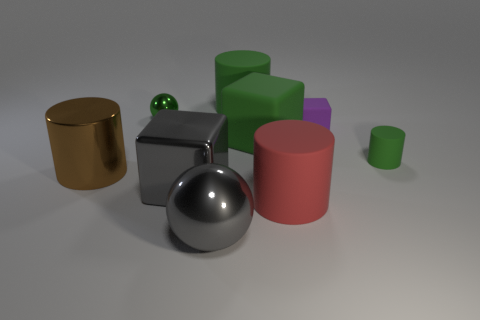Add 1 gray blocks. How many objects exist? 10 Subtract all cylinders. How many objects are left? 5 Add 1 green matte cylinders. How many green matte cylinders are left? 3 Add 2 large yellow matte cylinders. How many large yellow matte cylinders exist? 2 Subtract 0 gray cylinders. How many objects are left? 9 Subtract all small metal balls. Subtract all large brown metallic cylinders. How many objects are left? 7 